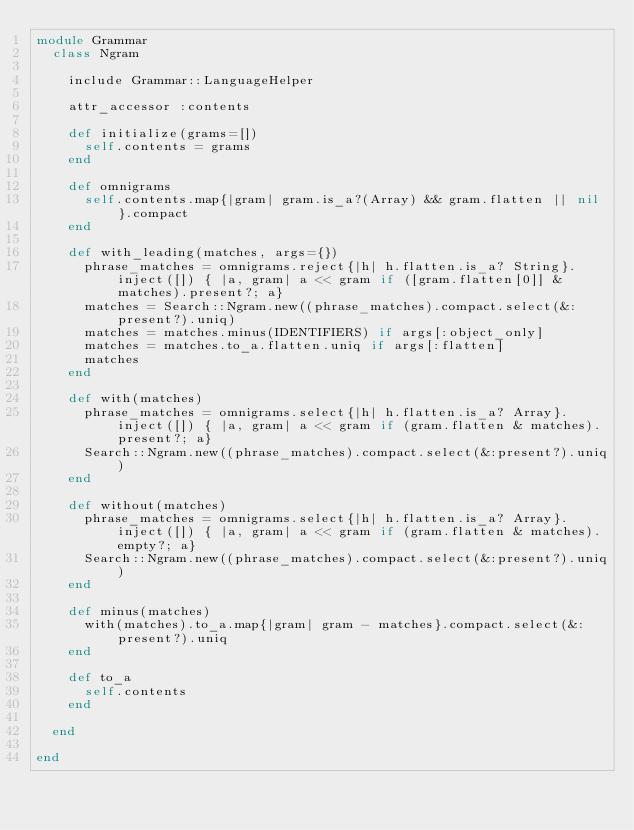<code> <loc_0><loc_0><loc_500><loc_500><_Ruby_>module Grammar
  class Ngram

    include Grammar::LanguageHelper

    attr_accessor :contents

    def initialize(grams=[])
      self.contents = grams
    end

    def omnigrams
      self.contents.map{|gram| gram.is_a?(Array) && gram.flatten || nil}.compact
    end

    def with_leading(matches, args={})
      phrase_matches = omnigrams.reject{|h| h.flatten.is_a? String}.inject([]) { |a, gram| a << gram if ([gram.flatten[0]] & matches).present?; a}
      matches = Search::Ngram.new((phrase_matches).compact.select(&:present?).uniq)
      matches = matches.minus(IDENTIFIERS) if args[:object_only]
      matches = matches.to_a.flatten.uniq if args[:flatten]
      matches
    end

    def with(matches)
      phrase_matches = omnigrams.select{|h| h.flatten.is_a? Array}.inject([]) { |a, gram| a << gram if (gram.flatten & matches).present?; a}
      Search::Ngram.new((phrase_matches).compact.select(&:present?).uniq)
    end

    def without(matches)
      phrase_matches = omnigrams.select{|h| h.flatten.is_a? Array}.inject([]) { |a, gram| a << gram if (gram.flatten & matches).empty?; a}
      Search::Ngram.new((phrase_matches).compact.select(&:present?).uniq)
    end

    def minus(matches)
      with(matches).to_a.map{|gram| gram - matches}.compact.select(&:present?).uniq
    end

    def to_a
      self.contents
    end

  end

end
</code> 